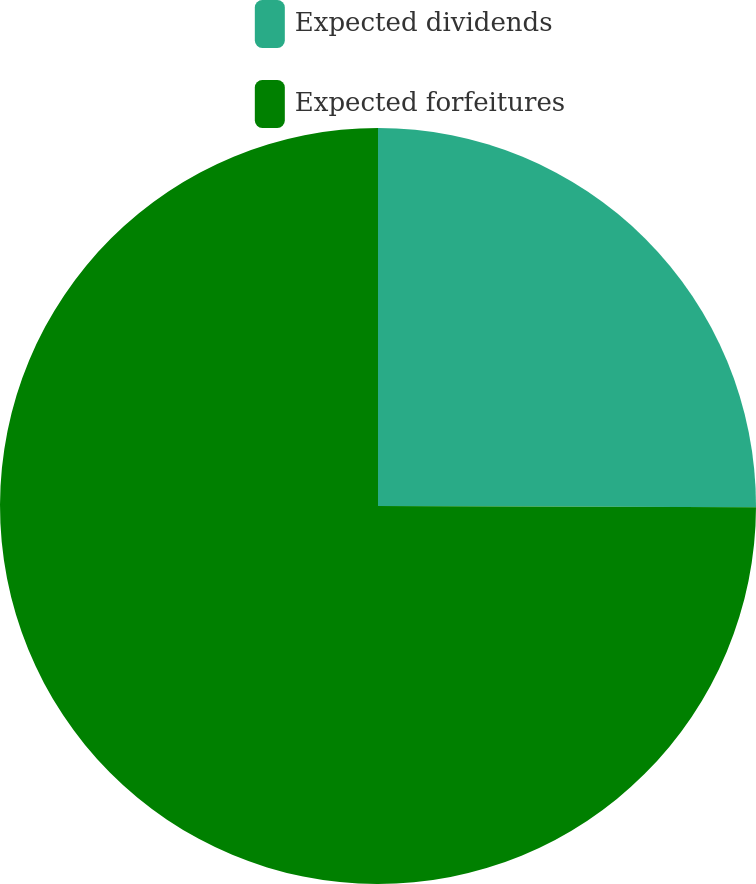<chart> <loc_0><loc_0><loc_500><loc_500><pie_chart><fcel>Expected dividends<fcel>Expected forfeitures<nl><fcel>25.05%<fcel>74.95%<nl></chart> 